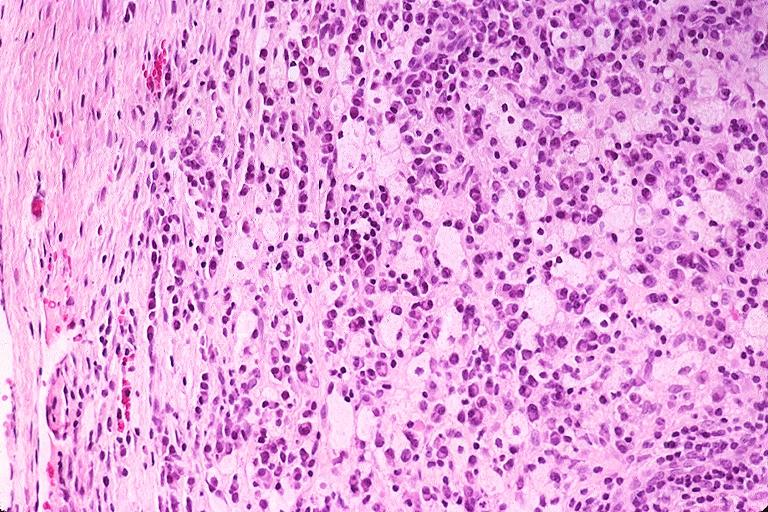where is this?
Answer the question using a single word or phrase. Oral 